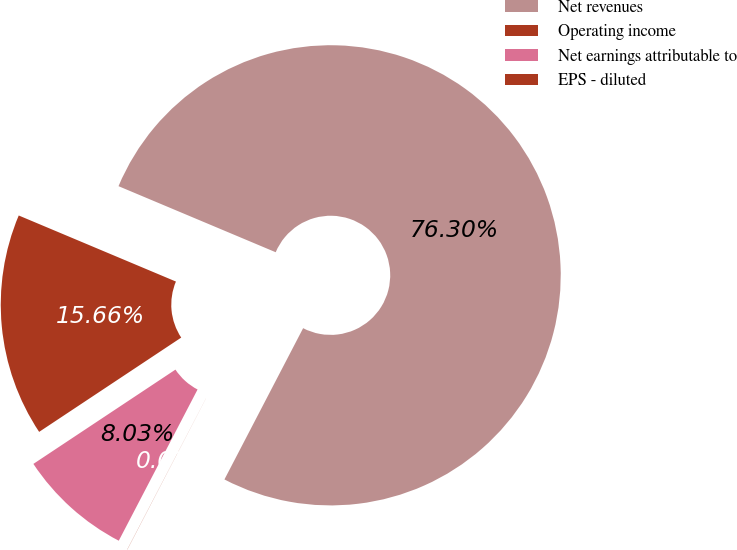Convert chart to OTSL. <chart><loc_0><loc_0><loc_500><loc_500><pie_chart><fcel>Net revenues<fcel>Operating income<fcel>Net earnings attributable to<fcel>EPS - diluted<nl><fcel>76.31%<fcel>15.66%<fcel>8.03%<fcel>0.01%<nl></chart> 